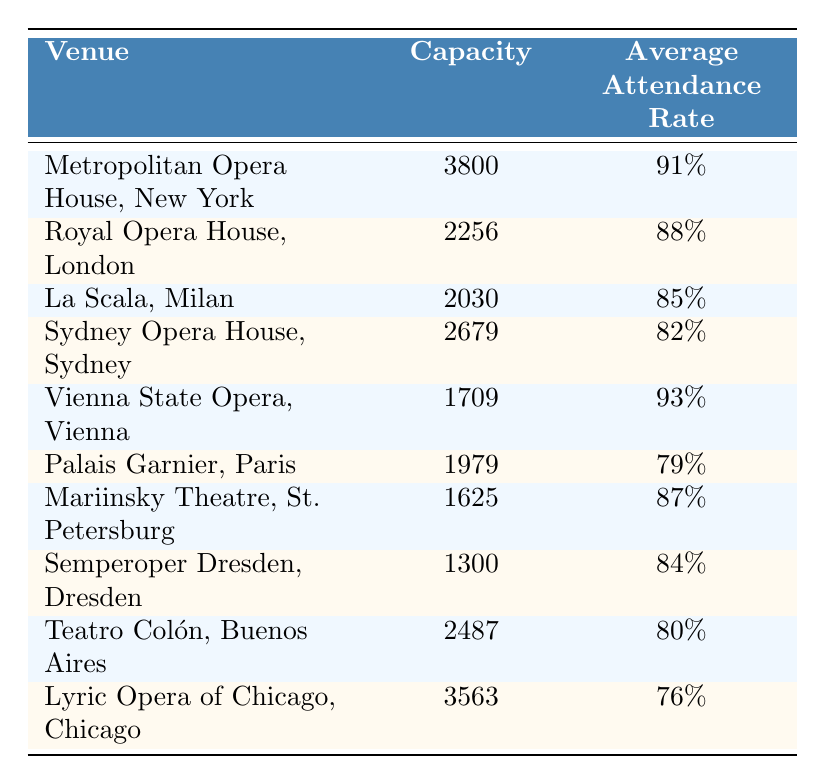What is the average attendance rate for the Metropolitan Opera House, New York? The table lists the average attendance rate for the Metropolitan Opera House as 91%.
Answer: 91% Which venue has the highest average attendance rate? By comparing the average attendance rates, the highest is 93%, associated with the Vienna State Opera, Vienna.
Answer: Vienna State Opera, Vienna Is the average attendance rate for Sydney Opera House above or below 85%? The average attendance rate for Sydney Opera House is 82%, which is below 85%.
Answer: Below What is the total capacity of all venues listed in the table? To find the total capacity, sum all values: 3800 + 2256 + 2030 + 2679 + 1709 + 1979 + 1625 + 1300 + 2487 + 3563 = 19628.
Answer: 19628 How many venues have an average attendance rate of 85% or higher? The venues with rates of 85% or higher are: Metropolitan Opera House, Royal Opera House, La Scala, Vienna State Opera, and Mariinsky Theatre, making a total of 5 venues.
Answer: 5 